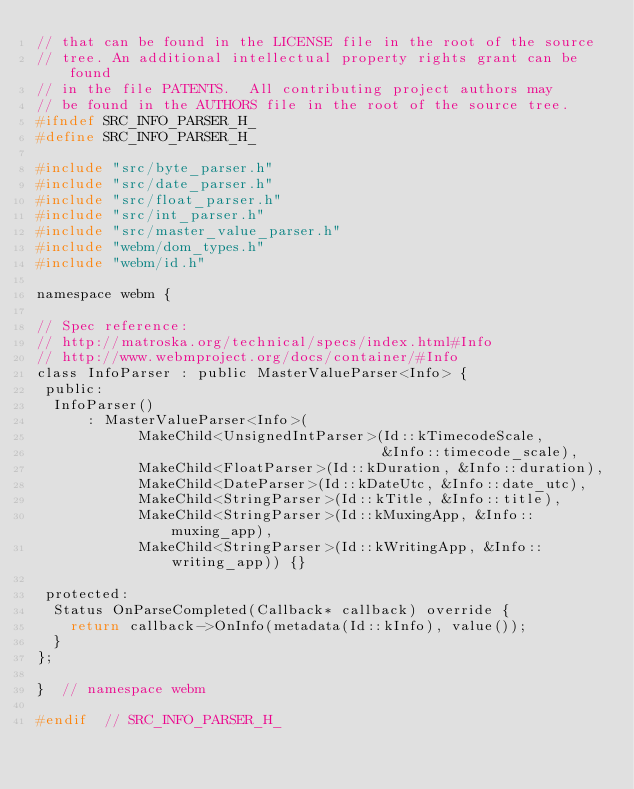Convert code to text. <code><loc_0><loc_0><loc_500><loc_500><_C_>// that can be found in the LICENSE file in the root of the source
// tree. An additional intellectual property rights grant can be found
// in the file PATENTS.  All contributing project authors may
// be found in the AUTHORS file in the root of the source tree.
#ifndef SRC_INFO_PARSER_H_
#define SRC_INFO_PARSER_H_

#include "src/byte_parser.h"
#include "src/date_parser.h"
#include "src/float_parser.h"
#include "src/int_parser.h"
#include "src/master_value_parser.h"
#include "webm/dom_types.h"
#include "webm/id.h"

namespace webm {

// Spec reference:
// http://matroska.org/technical/specs/index.html#Info
// http://www.webmproject.org/docs/container/#Info
class InfoParser : public MasterValueParser<Info> {
 public:
  InfoParser()
      : MasterValueParser<Info>(
            MakeChild<UnsignedIntParser>(Id::kTimecodeScale,
                                         &Info::timecode_scale),
            MakeChild<FloatParser>(Id::kDuration, &Info::duration),
            MakeChild<DateParser>(Id::kDateUtc, &Info::date_utc),
            MakeChild<StringParser>(Id::kTitle, &Info::title),
            MakeChild<StringParser>(Id::kMuxingApp, &Info::muxing_app),
            MakeChild<StringParser>(Id::kWritingApp, &Info::writing_app)) {}

 protected:
  Status OnParseCompleted(Callback* callback) override {
    return callback->OnInfo(metadata(Id::kInfo), value());
  }
};

}  // namespace webm

#endif  // SRC_INFO_PARSER_H_
</code> 